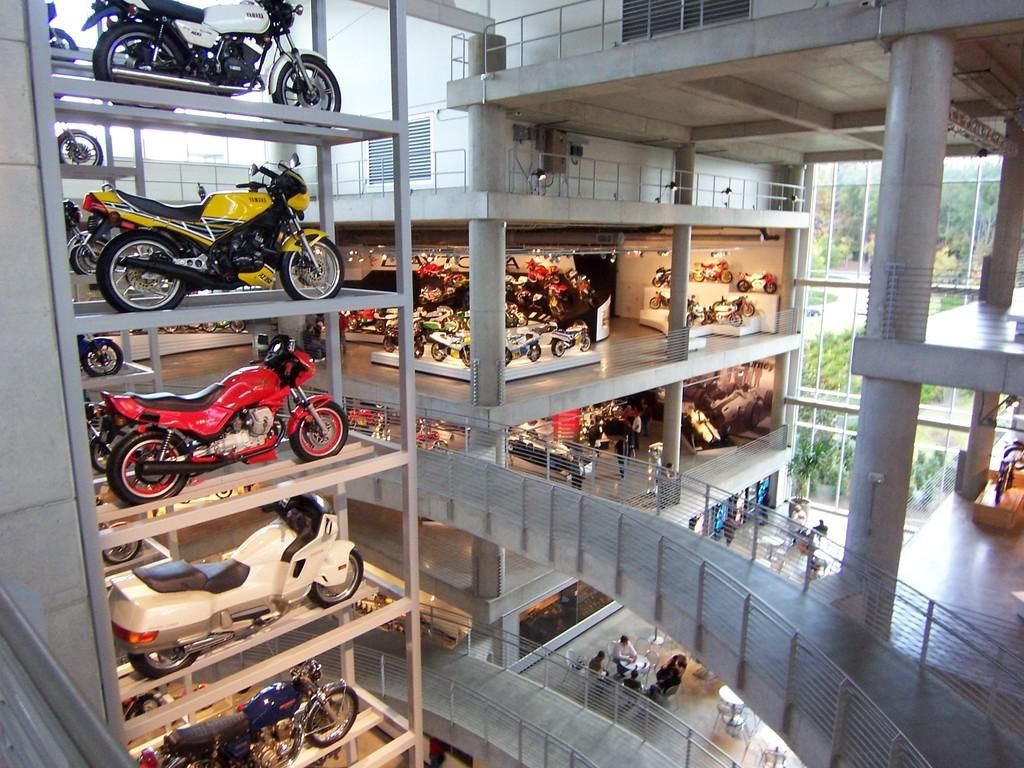What type of vehicles are displayed inside the building? There are bikes displayed inside the building. What can be seen outside the building? There is a view of trees outside the building. What type of camera is being used to capture the birthday celebration in the image? There is no camera or birthday celebration present in the image; it only shows bikes inside the building and trees outside. 